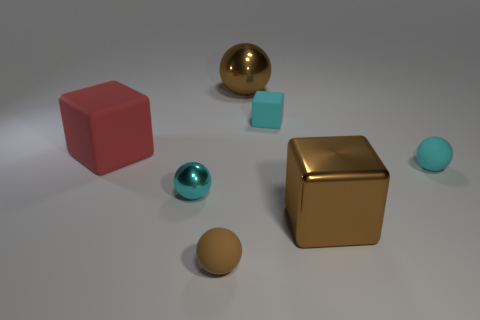What size is the metal ball that is the same color as the big metallic block?
Offer a terse response. Large. How many tiny brown spheres are the same material as the big red object?
Provide a short and direct response. 1. What color is the tiny matte sphere that is to the right of the small sphere in front of the brown cube?
Offer a terse response. Cyan. What number of things are either red matte objects or small rubber objects that are right of the big red thing?
Provide a succinct answer. 4. Are there any small matte cubes of the same color as the large shiny cube?
Provide a succinct answer. No. How many cyan objects are either tiny rubber things or big metal spheres?
Provide a short and direct response. 2. What number of other things are there of the same size as the red matte cube?
Your answer should be very brief. 2. What number of tiny objects are either rubber balls or shiny spheres?
Give a very brief answer. 3. There is a brown rubber sphere; is its size the same as the shiny sphere in front of the big ball?
Ensure brevity in your answer.  Yes. What number of other objects are there of the same shape as the tiny cyan metallic object?
Make the answer very short. 3. 